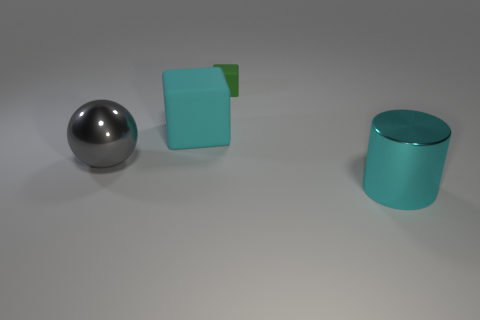There is a object that is behind the metal ball and on the right side of the cyan rubber object; what size is it?
Keep it short and to the point. Small. There is a tiny rubber object; what shape is it?
Provide a short and direct response. Cube. Are there any other things that have the same size as the green cube?
Provide a succinct answer. No. Is the number of large gray metallic objects left of the big cyan block greater than the number of large purple metallic things?
Your response must be concise. Yes. What shape is the large metallic thing that is behind the cyan object that is to the right of the big cyan object that is left of the cylinder?
Make the answer very short. Sphere. There is a cyan cube that is behind the metallic cylinder; is its size the same as the large gray thing?
Offer a very short reply. Yes. There is a thing that is both in front of the large rubber block and behind the cyan cylinder; what shape is it?
Offer a terse response. Sphere. There is a shiny sphere; is it the same color as the cube on the left side of the tiny matte object?
Offer a terse response. No. What is the color of the big metal object that is in front of the shiny thing on the left side of the metallic object that is in front of the large gray object?
Offer a terse response. Cyan. What is the color of the other rubber thing that is the same shape as the green matte object?
Your response must be concise. Cyan. 